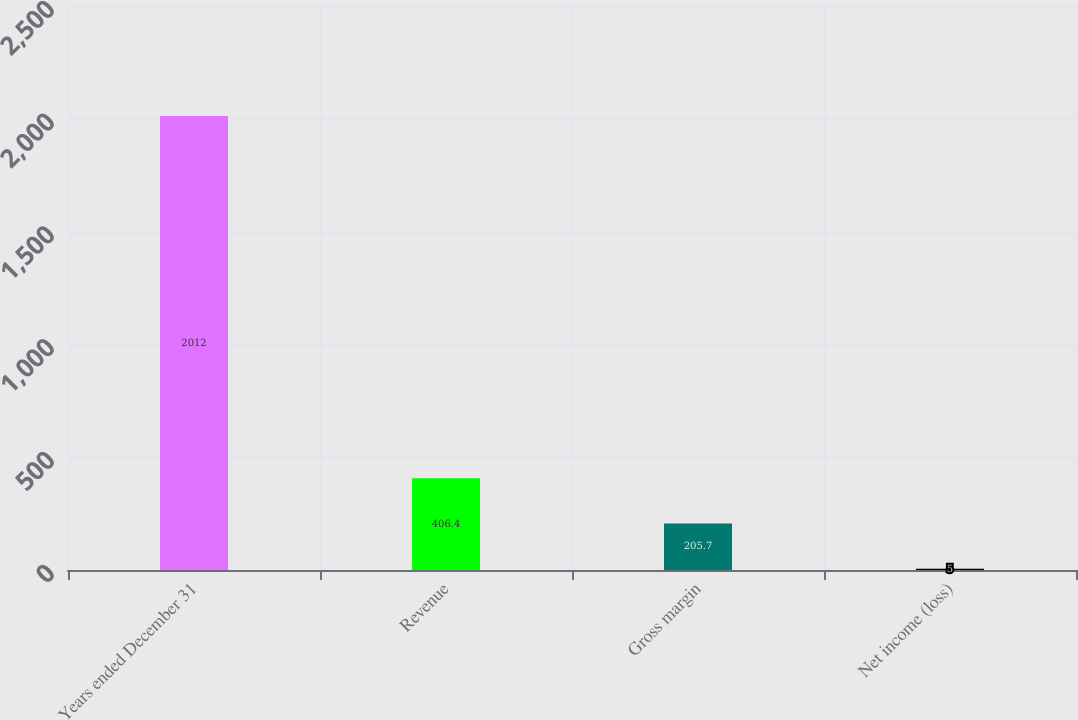Convert chart. <chart><loc_0><loc_0><loc_500><loc_500><bar_chart><fcel>Years ended December 31<fcel>Revenue<fcel>Gross margin<fcel>Net income (loss)<nl><fcel>2012<fcel>406.4<fcel>205.7<fcel>5<nl></chart> 